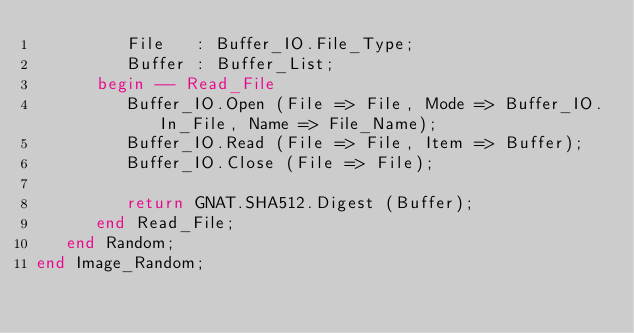<code> <loc_0><loc_0><loc_500><loc_500><_Ada_>         File   : Buffer_IO.File_Type;
         Buffer : Buffer_List;
      begin -- Read_File
         Buffer_IO.Open (File => File, Mode => Buffer_IO.In_File, Name => File_Name);
         Buffer_IO.Read (File => File, Item => Buffer);
         Buffer_IO.Close (File => File);

         return GNAT.SHA512.Digest (Buffer);
      end Read_File;
   end Random;
end Image_Random;
</code> 